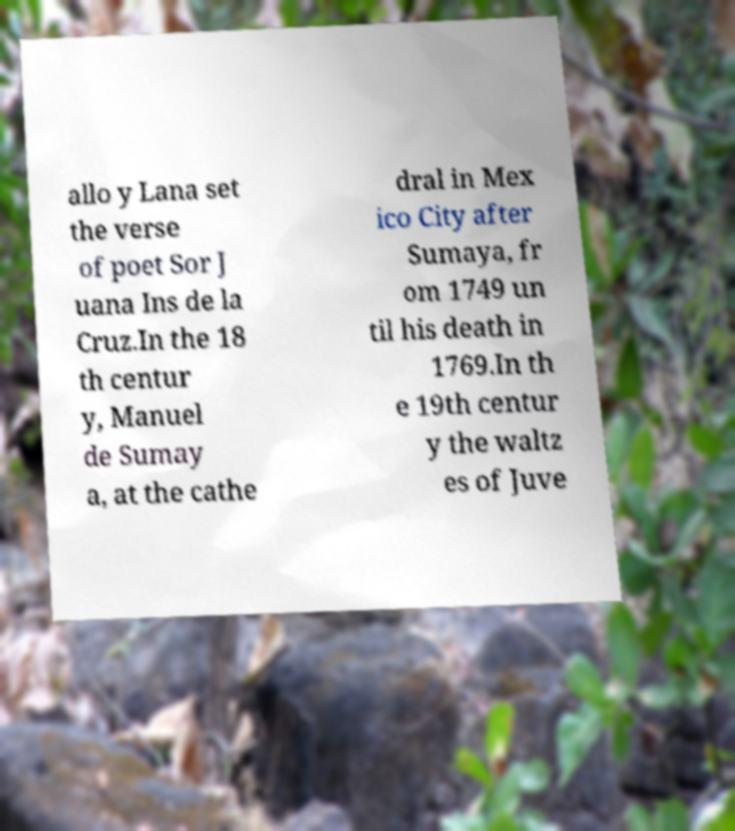Please identify and transcribe the text found in this image. allo y Lana set the verse of poet Sor J uana Ins de la Cruz.In the 18 th centur y, Manuel de Sumay a, at the cathe dral in Mex ico City after Sumaya, fr om 1749 un til his death in 1769.In th e 19th centur y the waltz es of Juve 